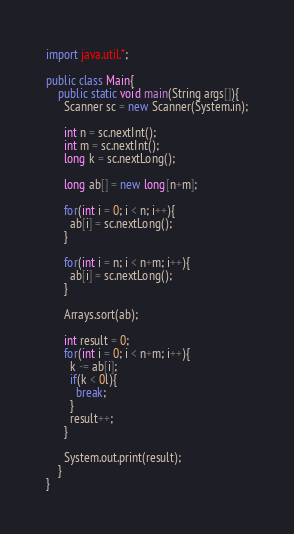Convert code to text. <code><loc_0><loc_0><loc_500><loc_500><_Java_>import java.util.*;

public class Main{
	public static void main(String args[]){
      Scanner sc = new Scanner(System.in);
      
      int n = sc.nextInt();
      int m = sc.nextInt();
      long k = sc.nextLong();
      
      long ab[] = new long[n+m];
      
      for(int i = 0; i < n; i++){
        ab[i] = sc.nextLong();
      }
      
      for(int i = n; i < n+m; i++){
        ab[i] = sc.nextLong();
      }
      
      Arrays.sort(ab);
      
      int result = 0;
      for(int i = 0; i < n+m; i++){
      	k -= ab[i];
        if(k < 0l){
          break;
        }
        result++;
      }
      
      System.out.print(result);
    }
}
</code> 